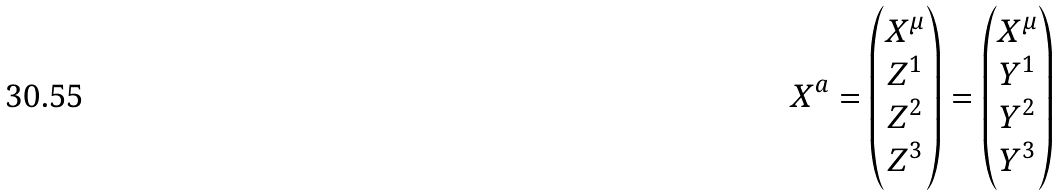Convert formula to latex. <formula><loc_0><loc_0><loc_500><loc_500>X ^ { a } = \begin{pmatrix} X ^ { \mu } \\ Z ^ { 1 } \\ Z ^ { 2 } \\ Z ^ { 3 } \\ \end{pmatrix} = \begin{pmatrix} X ^ { \mu } \\ Y ^ { 1 } \\ Y ^ { 2 } \\ Y ^ { 3 } \end{pmatrix}</formula> 